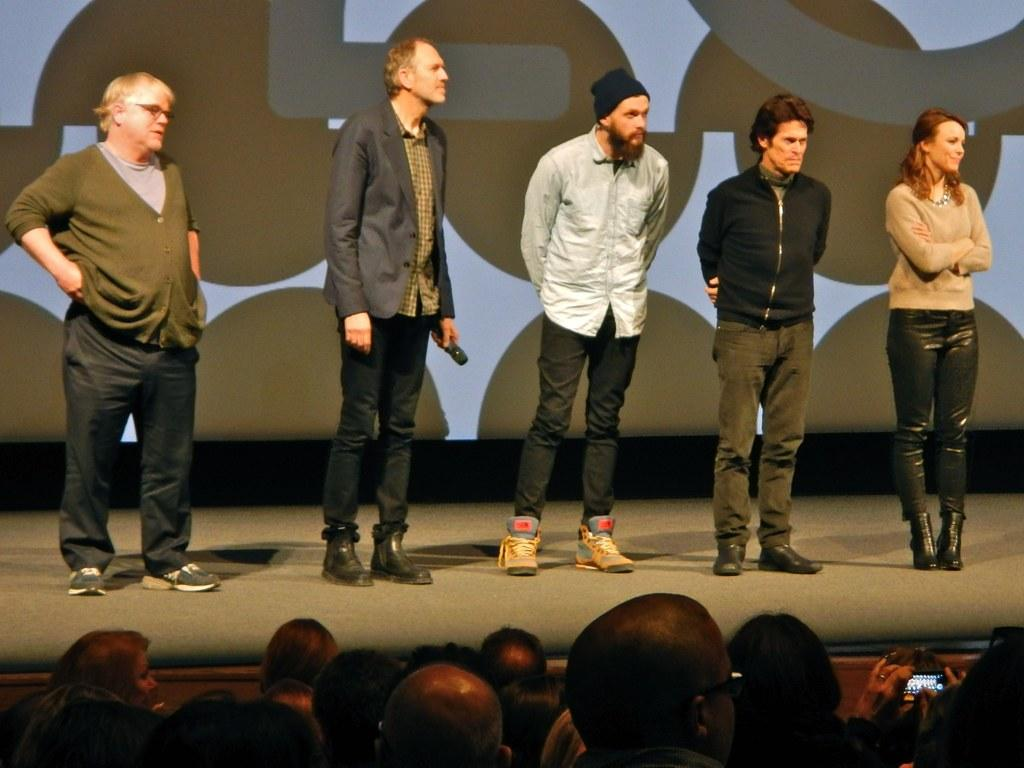How many people are on the stage in the image? There are five persons standing on the stage. What is one of the persons holding in their hand? One of the persons is holding a microphone in their hand. Can you describe the group of people present in the image? There is a group of people present in the image. What type of treatment is being administered to the clouds in the image? There are no clouds present in the image, and therefore no treatment is being administered to them. Is anyone driving a vehicle in the image? There is no vehicle or driving activity depicted in the image. 